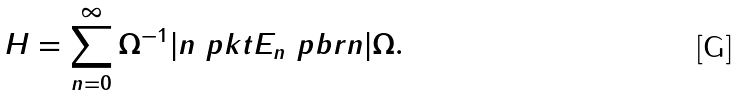Convert formula to latex. <formula><loc_0><loc_0><loc_500><loc_500>H = \sum _ { n = 0 } ^ { \infty } \Omega ^ { - 1 } | n \ p k t E _ { n } \ p b r n | \Omega .</formula> 